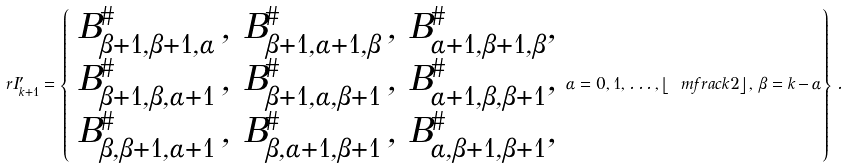<formula> <loc_0><loc_0><loc_500><loc_500>\ r I ^ { \prime } _ { k + 1 } = \left \{ \begin{array} { l } B _ { \beta + 1 , \beta + 1 , \alpha } ^ { \# } \, , \, B _ { \beta + 1 , \alpha + 1 , \beta } ^ { \# } \, , \, B _ { \alpha + 1 , \beta + 1 , \beta } ^ { \# } , \\ B _ { \beta + 1 , \beta , \alpha + 1 } ^ { \# } \, , \, B _ { \beta + 1 , \alpha , \beta + 1 } ^ { \# } \, , \, B _ { \alpha + 1 , \beta , \beta + 1 } ^ { \# } , \\ B _ { \beta , \beta + 1 , \alpha + 1 } ^ { \# } \, , \, B _ { \beta , \alpha + 1 , \beta + 1 } ^ { \# } \, , \, B _ { \alpha , \beta + 1 , \beta + 1 } ^ { \# } , \end{array} \alpha = 0 , 1 , \dots , \left \lfloor \ m f r a c { k } { 2 } \right \rfloor , \, \beta = k \, { - } \, \alpha \right \} \, .</formula> 